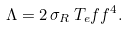<formula> <loc_0><loc_0><loc_500><loc_500>\Lambda = 2 \, \sigma _ { R } \, T _ { e } f f ^ { 4 } .</formula> 